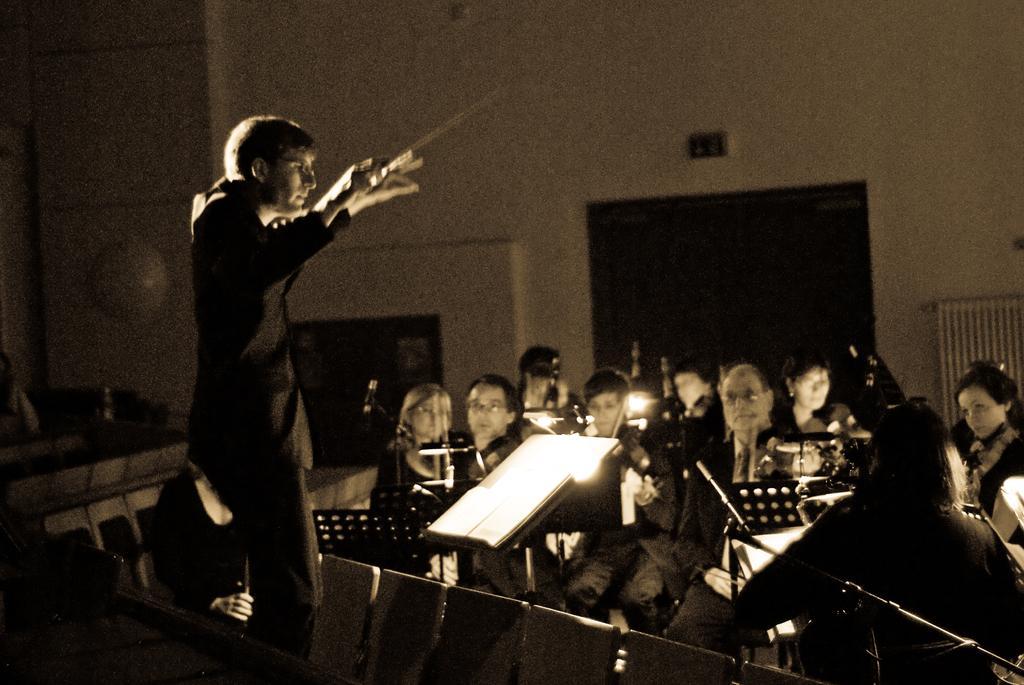Please provide a concise description of this image. In the picture we can see a man standing and giving a training of playing a musical instrument and he is wearing black color blazer and in front of him we can see some people are standing and playing a musical instrument and in the background we can see a wall with some doors to it. 